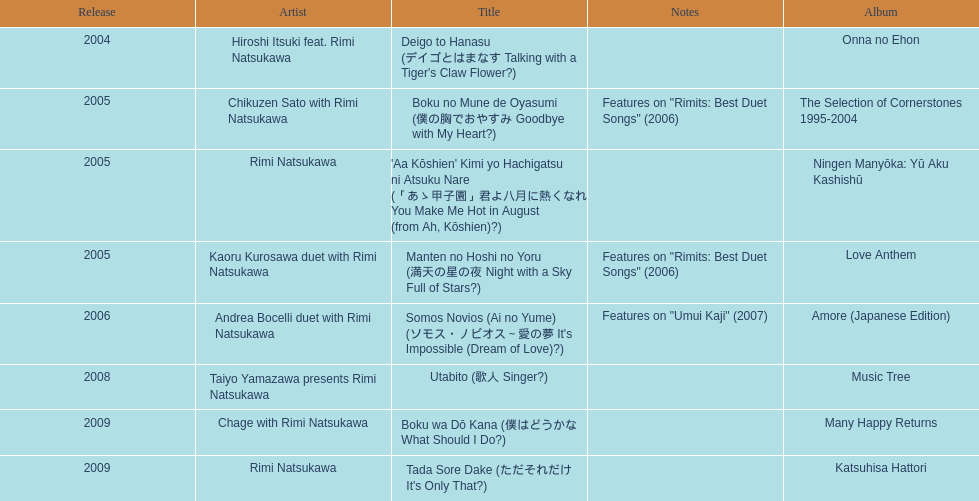What is the total count of albums rimi natsukawa has put out? 8. Would you mind parsing the complete table? {'header': ['Release', 'Artist', 'Title', 'Notes', 'Album'], 'rows': [['2004', 'Hiroshi Itsuki feat. Rimi Natsukawa', "Deigo to Hanasu (デイゴとはまなす Talking with a Tiger's Claw Flower?)", '', 'Onna no Ehon'], ['2005', 'Chikuzen Sato with Rimi Natsukawa', 'Boku no Mune de Oyasumi (僕の胸でおやすみ Goodbye with My Heart?)', 'Features on "Rimits: Best Duet Songs" (2006)', 'The Selection of Cornerstones 1995-2004'], ['2005', 'Rimi Natsukawa', "'Aa Kōshien' Kimi yo Hachigatsu ni Atsuku Nare (「あゝ甲子園」君よ八月に熱くなれ You Make Me Hot in August (from Ah, Kōshien)?)", '', 'Ningen Manyōka: Yū Aku Kashishū'], ['2005', 'Kaoru Kurosawa duet with Rimi Natsukawa', 'Manten no Hoshi no Yoru (満天の星の夜 Night with a Sky Full of Stars?)', 'Features on "Rimits: Best Duet Songs" (2006)', 'Love Anthem'], ['2006', 'Andrea Bocelli duet with Rimi Natsukawa', "Somos Novios (Ai no Yume) (ソモス・ノビオス～愛の夢 It's Impossible (Dream of Love)?)", 'Features on "Umui Kaji" (2007)', 'Amore (Japanese Edition)'], ['2008', 'Taiyo Yamazawa presents Rimi Natsukawa', 'Utabito (歌人 Singer?)', '', 'Music Tree'], ['2009', 'Chage with Rimi Natsukawa', 'Boku wa Dō Kana (僕はどうかな What Should I Do?)', '', 'Many Happy Returns'], ['2009', 'Rimi Natsukawa', "Tada Sore Dake (ただそれだけ It's Only That?)", '', 'Katsuhisa Hattori']]} 